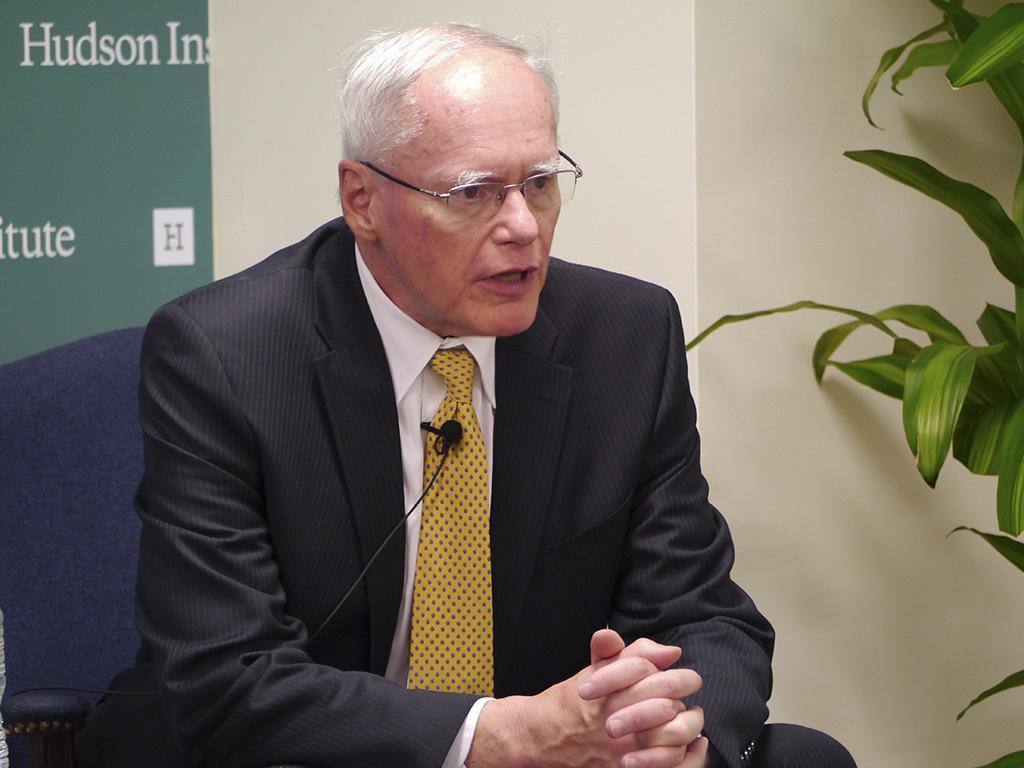What is the main subject of the image? There is a man in the image. What is the man wearing? The man is wearing a blazer, a tie, and spectacles. What is the man doing in the image? The man is sitting on a chair. What can be seen in the background of the image? There is a wall and leaves in the background of the image. Is the man being attacked by water in the image? There is no water present in the image, and therefore no such attack can be observed. 